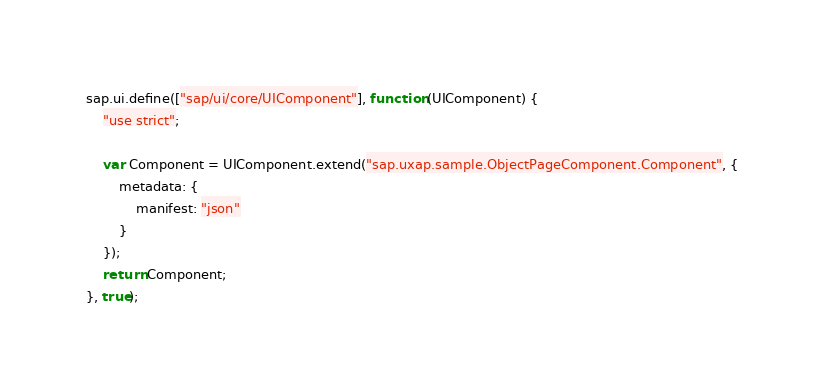Convert code to text. <code><loc_0><loc_0><loc_500><loc_500><_JavaScript_>sap.ui.define(["sap/ui/core/UIComponent"], function (UIComponent) {
	"use strict";

	var Component = UIComponent.extend("sap.uxap.sample.ObjectPageComponent.Component", {
		metadata: {
		    manifest: "json"
		}
	});
	return Component;
}, true);
</code> 